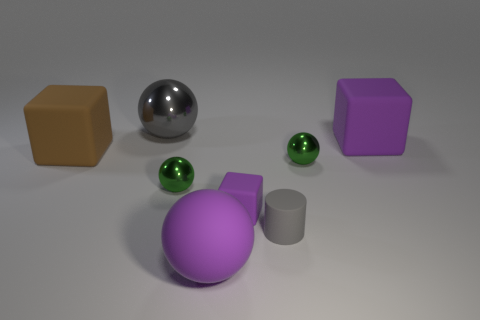There is a matte cylinder; are there any matte blocks to the left of it?
Your response must be concise. Yes. What number of things are purple rubber objects that are behind the cylinder or metallic objects that are left of the purple matte ball?
Give a very brief answer. 4. How many large cubes are the same color as the big shiny thing?
Provide a succinct answer. 0. What color is the other big matte object that is the same shape as the large gray thing?
Keep it short and to the point. Purple. There is a rubber object that is both in front of the brown rubber object and behind the small gray thing; what shape is it?
Your answer should be very brief. Cube. Are there more small brown metallic cylinders than small cylinders?
Ensure brevity in your answer.  No. What is the material of the small purple block?
Your answer should be compact. Rubber. Is there any other thing that has the same size as the gray shiny ball?
Offer a terse response. Yes. What size is the other purple thing that is the same shape as the tiny purple object?
Your answer should be very brief. Large. Are there any small purple blocks that are in front of the green sphere that is right of the big rubber ball?
Keep it short and to the point. Yes. 